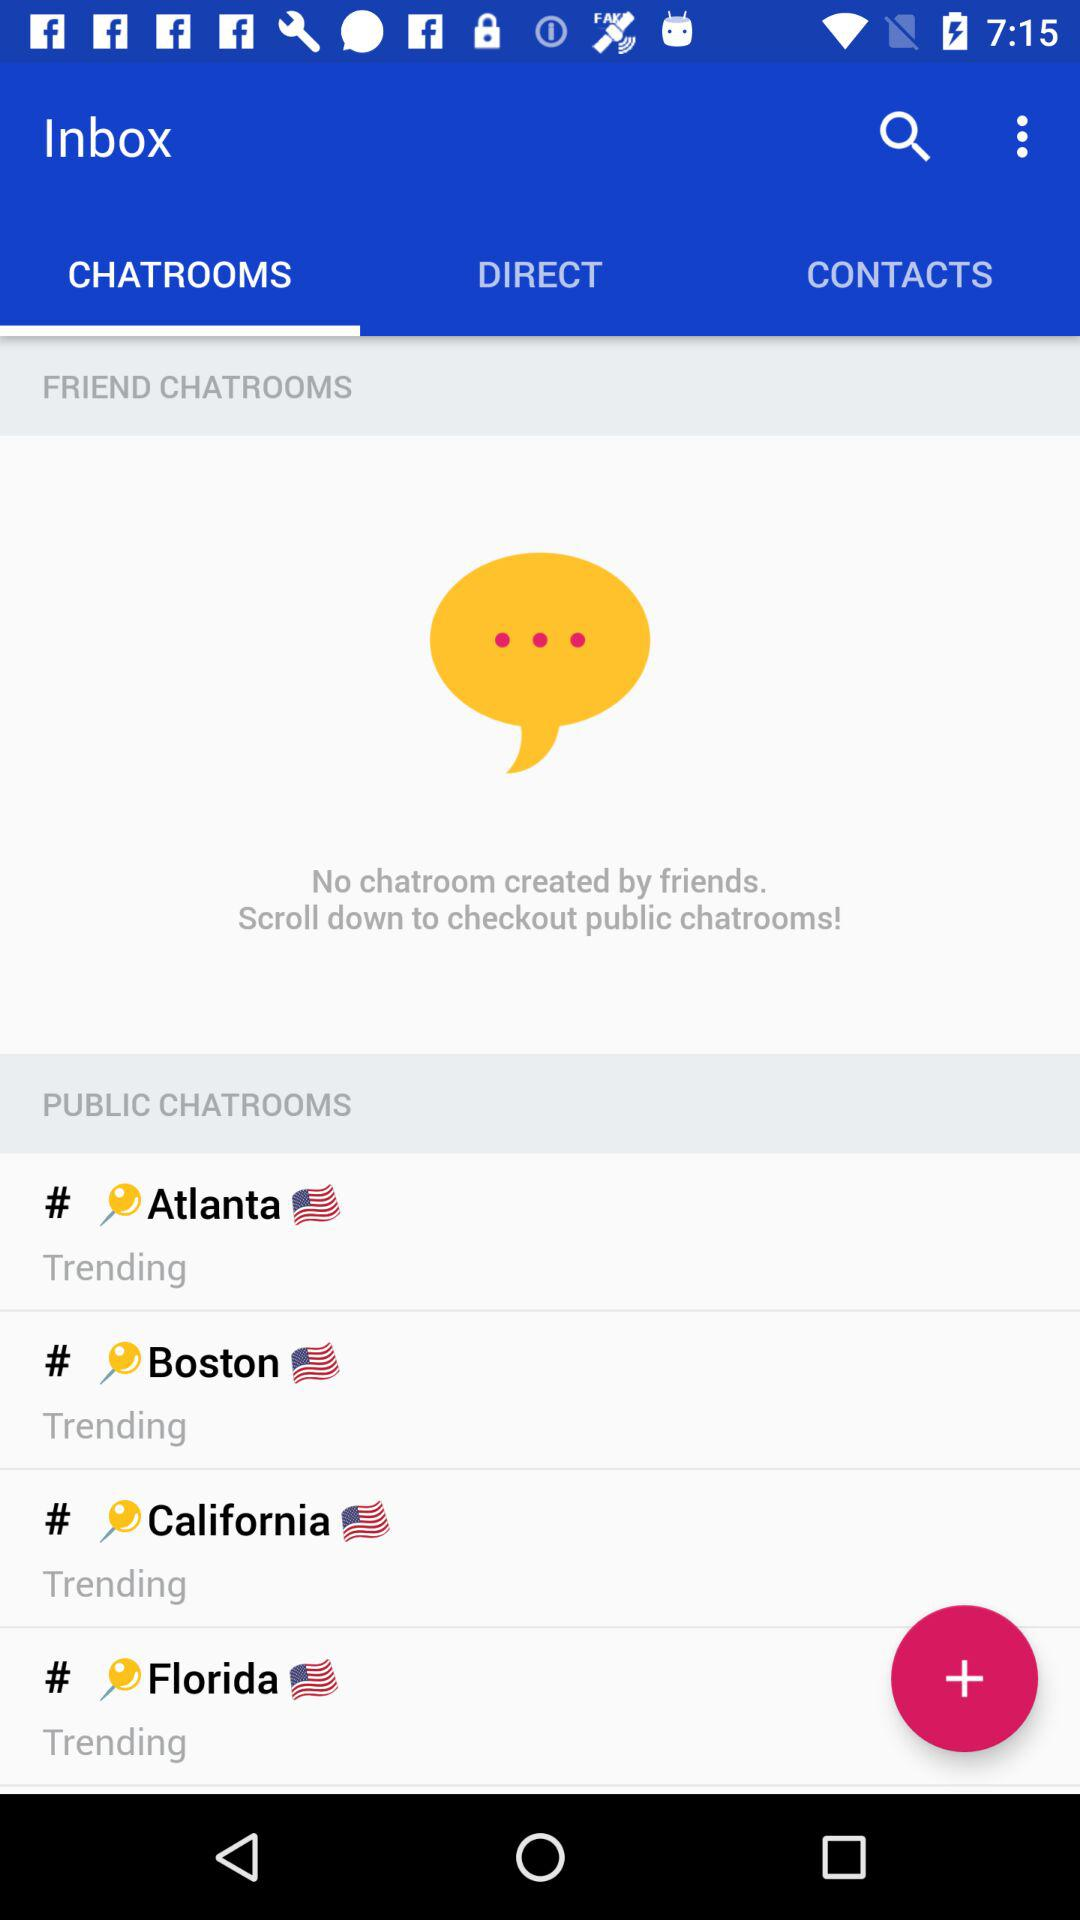How many more public chatrooms are there than friend chatrooms?
Answer the question using a single word or phrase. 4 